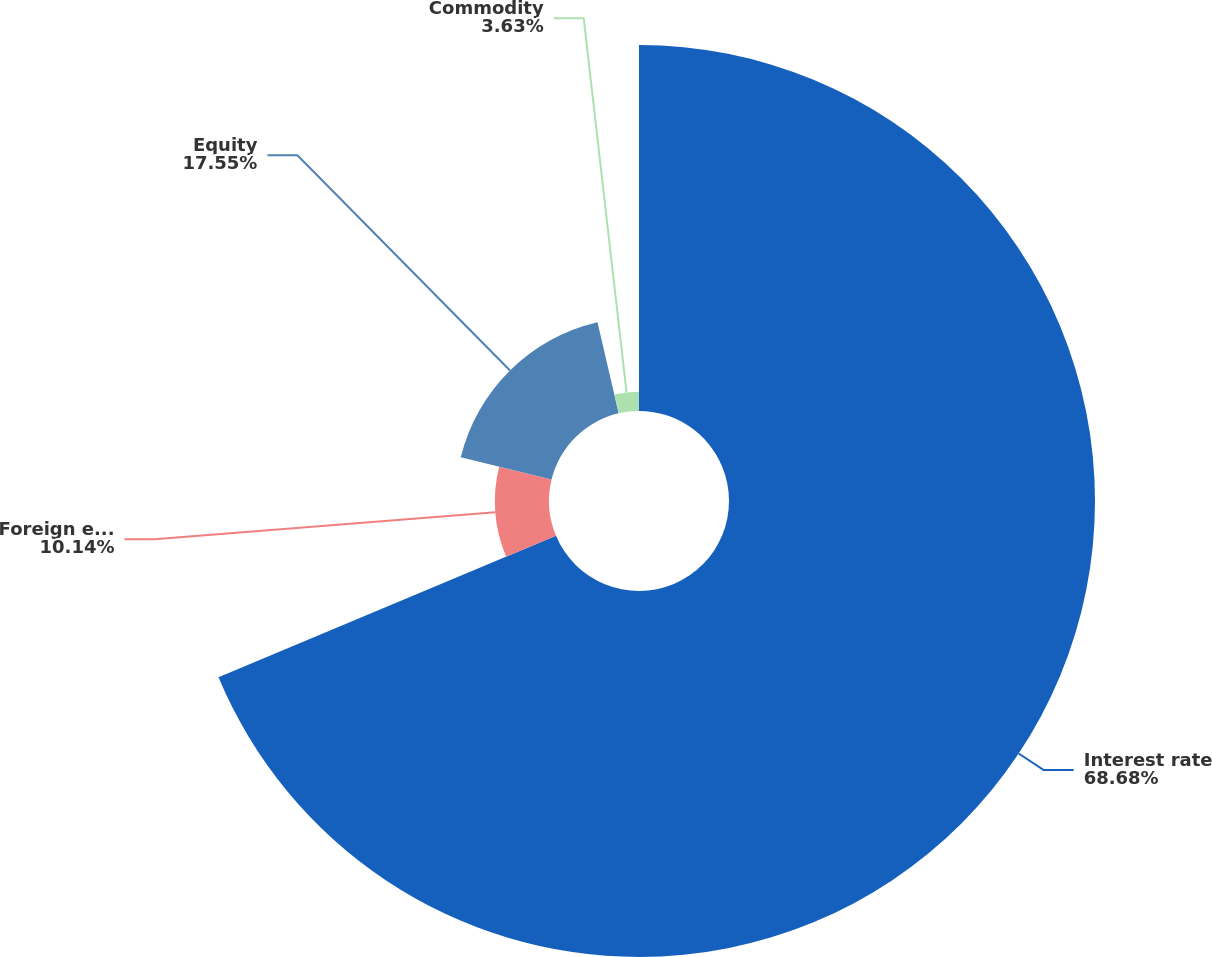Convert chart. <chart><loc_0><loc_0><loc_500><loc_500><pie_chart><fcel>Interest rate<fcel>Foreign exchange<fcel>Equity<fcel>Commodity<nl><fcel>68.68%<fcel>10.14%<fcel>17.55%<fcel>3.63%<nl></chart> 